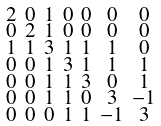Convert formula to latex. <formula><loc_0><loc_0><loc_500><loc_500>\begin{smallmatrix} 2 & 0 & 1 & 0 & 0 & 0 & 0 \\ 0 & 2 & 1 & 0 & 0 & 0 & 0 \\ 1 & 1 & 3 & 1 & 1 & 1 & 0 \\ 0 & 0 & 1 & 3 & 1 & 1 & 1 \\ 0 & 0 & 1 & 1 & 3 & 0 & 1 \\ 0 & 0 & 1 & 1 & 0 & 3 & - 1 \\ 0 & 0 & 0 & 1 & 1 & - 1 & 3 \end{smallmatrix}</formula> 